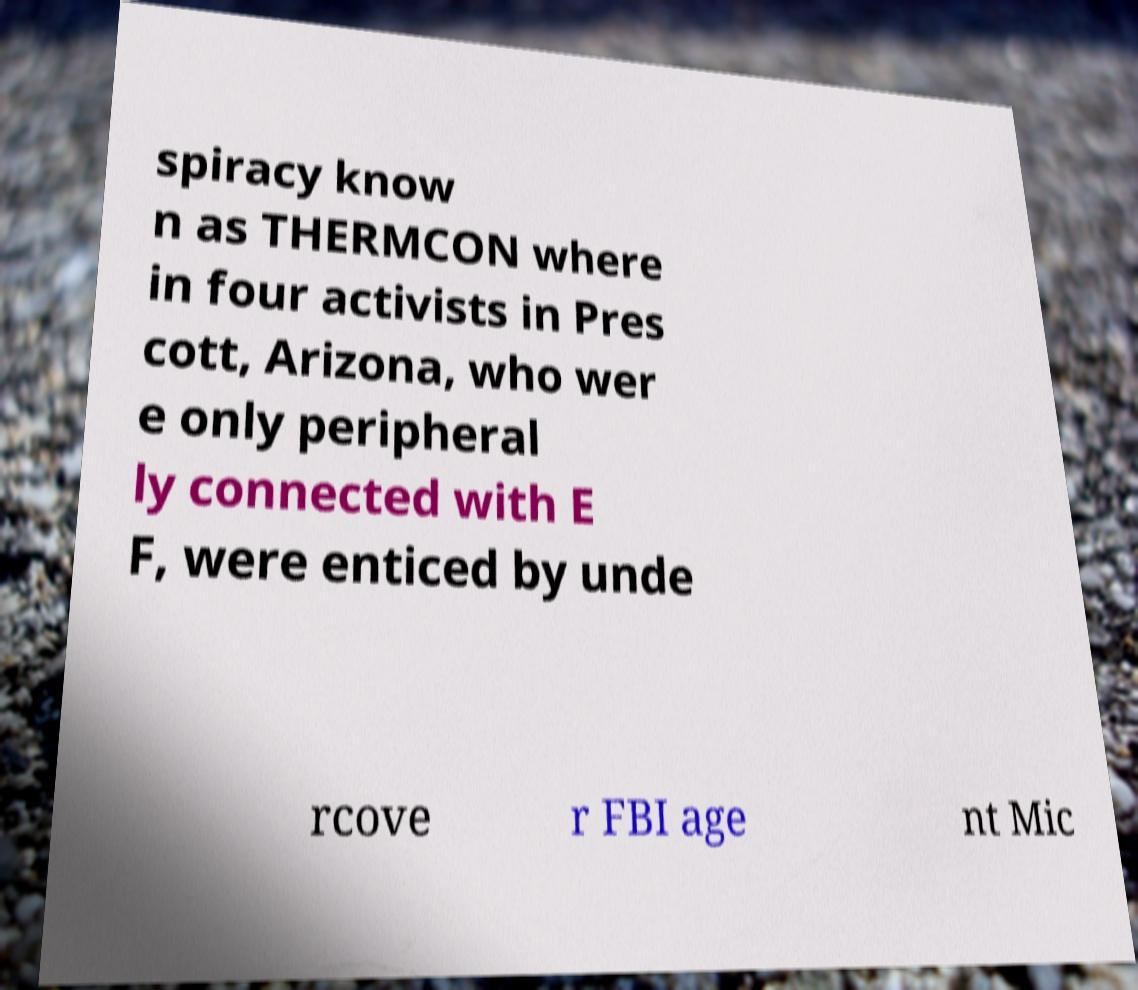Please read and relay the text visible in this image. What does it say? spiracy know n as THERMCON where in four activists in Pres cott, Arizona, who wer e only peripheral ly connected with E F, were enticed by unde rcove r FBI age nt Mic 